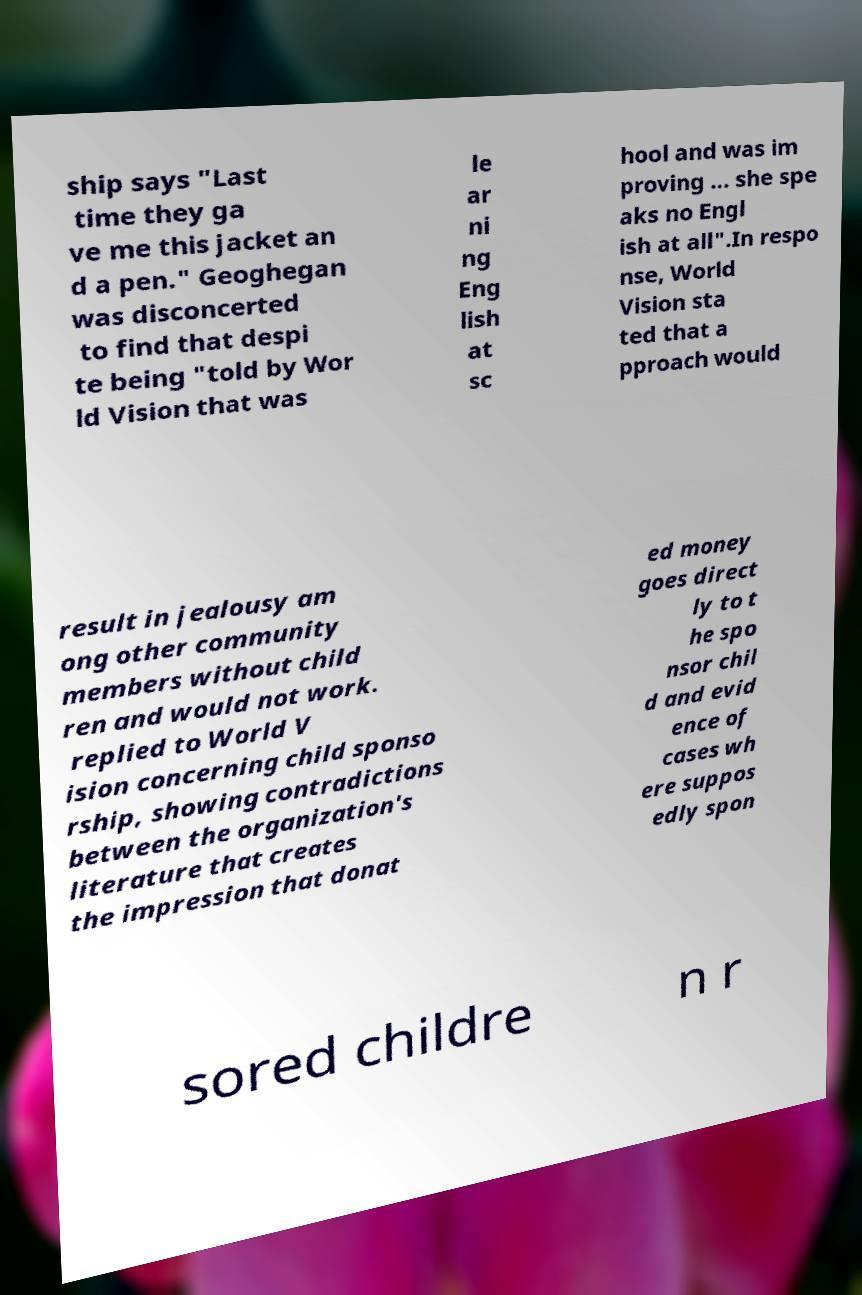Could you assist in decoding the text presented in this image and type it out clearly? ship says "Last time they ga ve me this jacket an d a pen." Geoghegan was disconcerted to find that despi te being "told by Wor ld Vision that was le ar ni ng Eng lish at sc hool and was im proving ... she spe aks no Engl ish at all".In respo nse, World Vision sta ted that a pproach would result in jealousy am ong other community members without child ren and would not work. replied to World V ision concerning child sponso rship, showing contradictions between the organization's literature that creates the impression that donat ed money goes direct ly to t he spo nsor chil d and evid ence of cases wh ere suppos edly spon sored childre n r 